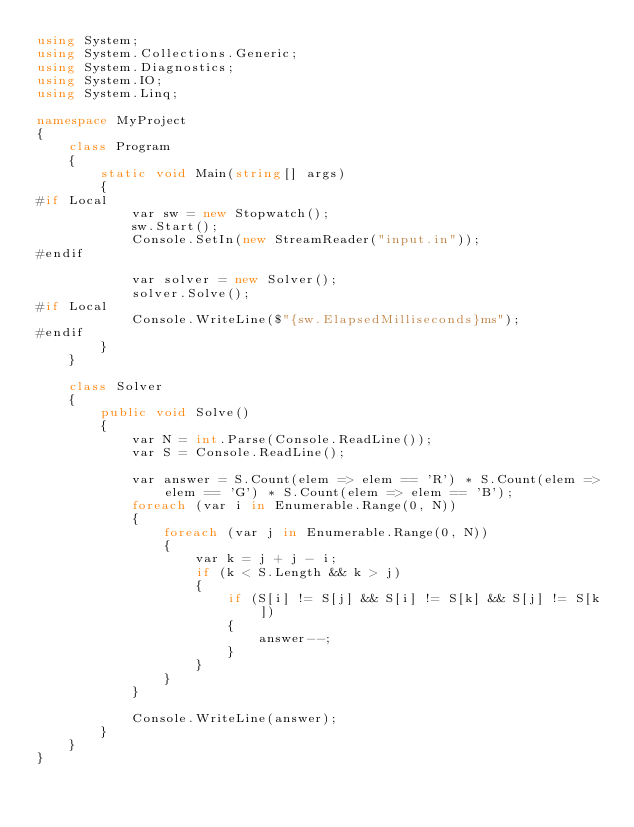<code> <loc_0><loc_0><loc_500><loc_500><_C#_>using System;
using System.Collections.Generic;
using System.Diagnostics;
using System.IO;
using System.Linq;

namespace MyProject
{
    class Program
    {
        static void Main(string[] args)
        {
#if Local
            var sw = new Stopwatch();
            sw.Start();
            Console.SetIn(new StreamReader("input.in"));
#endif

            var solver = new Solver();
            solver.Solve();
#if Local
            Console.WriteLine($"{sw.ElapsedMilliseconds}ms");
#endif
        }
    }

    class Solver
    {
        public void Solve()
        {
            var N = int.Parse(Console.ReadLine());
            var S = Console.ReadLine();

            var answer = S.Count(elem => elem == 'R') * S.Count(elem => elem == 'G') * S.Count(elem => elem == 'B');
            foreach (var i in Enumerable.Range(0, N))
            {
                foreach (var j in Enumerable.Range(0, N))
                {
                    var k = j + j - i;
                    if (k < S.Length && k > j)
                    {
                        if (S[i] != S[j] && S[i] != S[k] && S[j] != S[k])
                        {
                            answer--;
                        }
                    }
                }
            }

            Console.WriteLine(answer);
        }
    }
}
</code> 